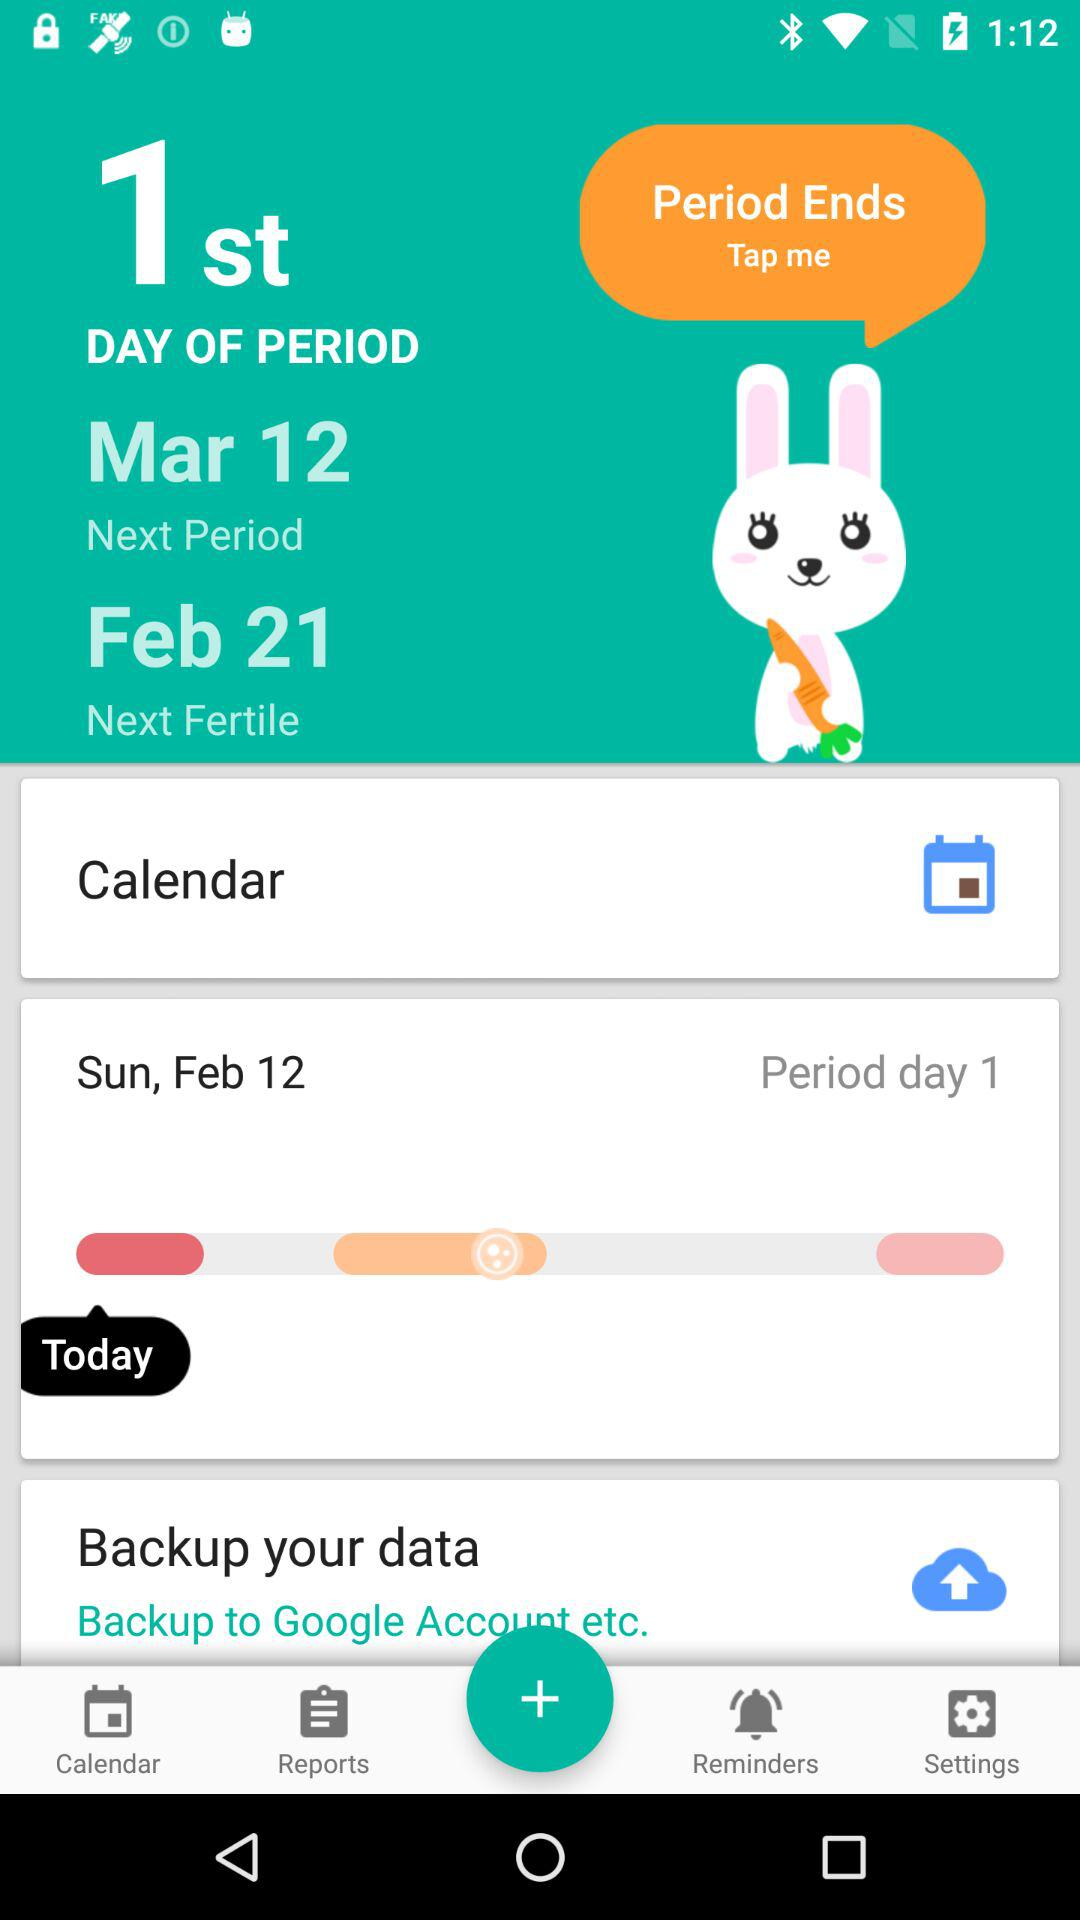What is the first day of the period? The first day of the period is Sunday, February 12. 